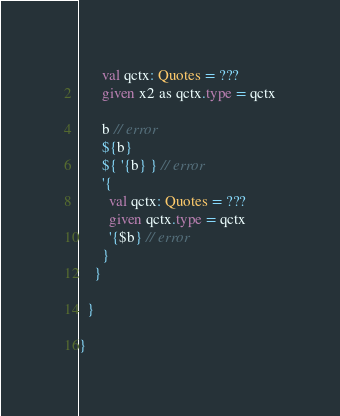<code> <loc_0><loc_0><loc_500><loc_500><_Scala_>      val qctx: Quotes = ???
      given x2 as qctx.type = qctx

      b // error
      ${b}
      ${ '{b} } // error
      '{
        val qctx: Quotes = ???
        given qctx.type = qctx
        '{$b} // error
      }
    }

  }

}
</code> 